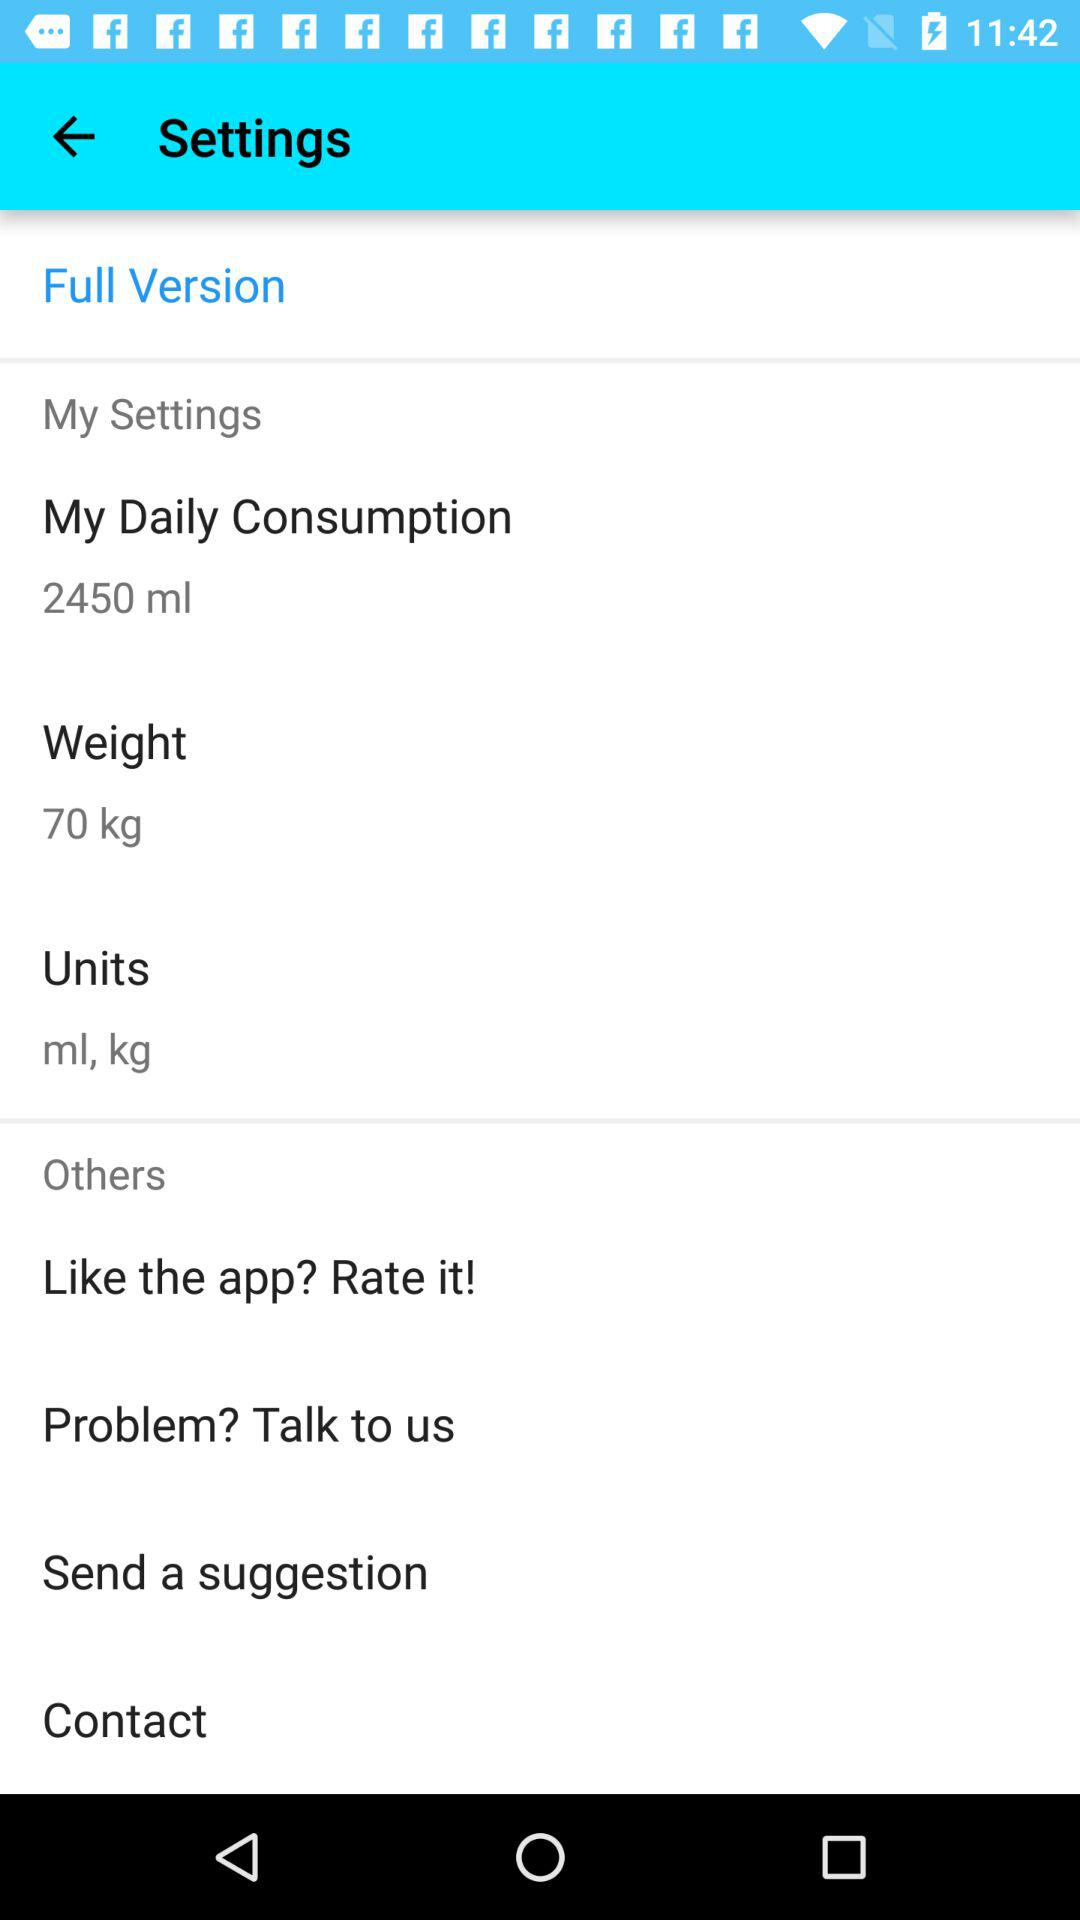How many ml is the user consuming daily?
Answer the question using a single word or phrase. 2450 